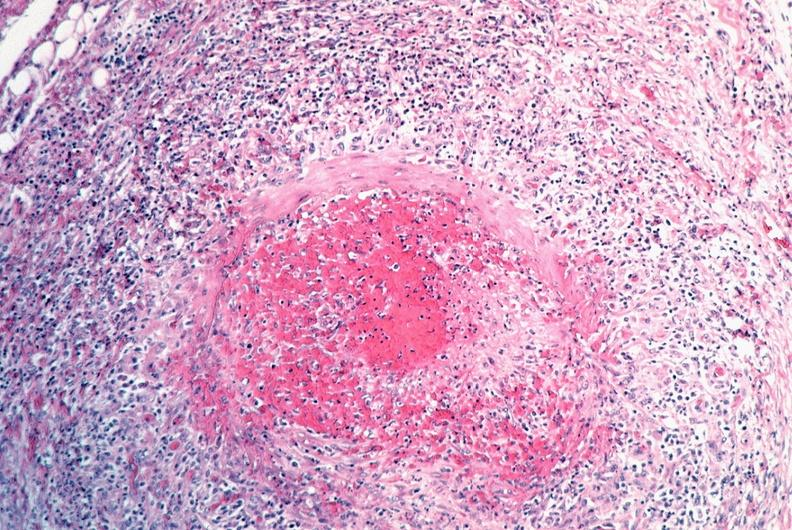s lower chest and abdomen anterior present?
Answer the question using a single word or phrase. No 